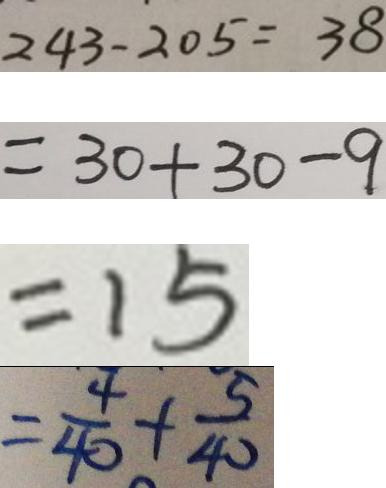<formula> <loc_0><loc_0><loc_500><loc_500>2 4 3 - 2 0 5 = 3 8 
 = 3 0 + 3 0 - 9 
 = 1 5 
 = \frac { 4 } { 4 0 } + \frac { 5 } { 4 0 }</formula> 